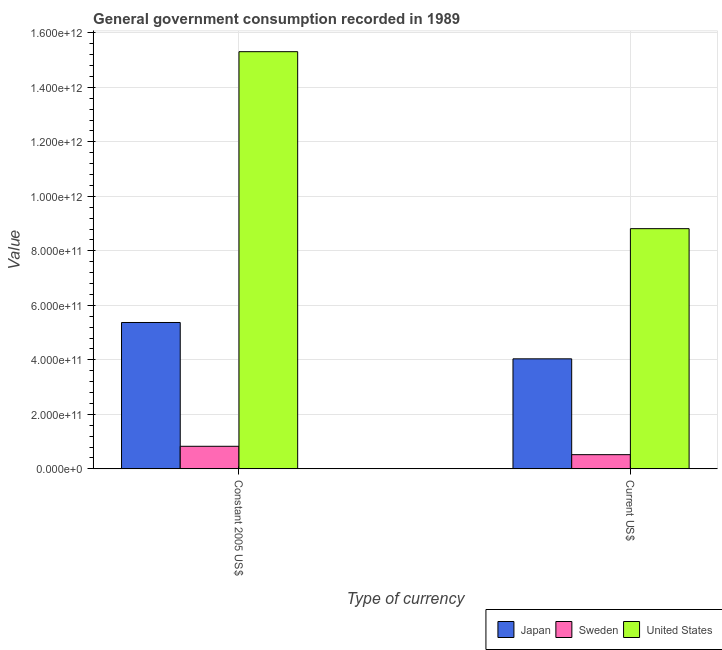How many groups of bars are there?
Your answer should be very brief. 2. Are the number of bars on each tick of the X-axis equal?
Your answer should be very brief. Yes. How many bars are there on the 2nd tick from the left?
Give a very brief answer. 3. How many bars are there on the 2nd tick from the right?
Your response must be concise. 3. What is the label of the 2nd group of bars from the left?
Make the answer very short. Current US$. What is the value consumed in current us$ in Sweden?
Offer a very short reply. 5.20e+1. Across all countries, what is the maximum value consumed in constant 2005 us$?
Your answer should be very brief. 1.53e+12. Across all countries, what is the minimum value consumed in current us$?
Make the answer very short. 5.20e+1. In which country was the value consumed in constant 2005 us$ maximum?
Offer a very short reply. United States. What is the total value consumed in current us$ in the graph?
Your answer should be very brief. 1.34e+12. What is the difference between the value consumed in current us$ in Sweden and that in Japan?
Make the answer very short. -3.52e+11. What is the difference between the value consumed in current us$ in Sweden and the value consumed in constant 2005 us$ in Japan?
Offer a terse response. -4.85e+11. What is the average value consumed in constant 2005 us$ per country?
Offer a terse response. 7.17e+11. What is the difference between the value consumed in current us$ and value consumed in constant 2005 us$ in Sweden?
Keep it short and to the point. -3.07e+1. What is the ratio of the value consumed in current us$ in Sweden to that in United States?
Your response must be concise. 0.06. In how many countries, is the value consumed in current us$ greater than the average value consumed in current us$ taken over all countries?
Your response must be concise. 1. What does the 2nd bar from the left in Current US$ represents?
Provide a short and direct response. Sweden. How many bars are there?
Offer a very short reply. 6. What is the difference between two consecutive major ticks on the Y-axis?
Keep it short and to the point. 2.00e+11. Are the values on the major ticks of Y-axis written in scientific E-notation?
Give a very brief answer. Yes. Does the graph contain any zero values?
Provide a short and direct response. No. Does the graph contain grids?
Keep it short and to the point. Yes. How are the legend labels stacked?
Offer a terse response. Horizontal. What is the title of the graph?
Offer a terse response. General government consumption recorded in 1989. What is the label or title of the X-axis?
Give a very brief answer. Type of currency. What is the label or title of the Y-axis?
Ensure brevity in your answer.  Value. What is the Value of Japan in Constant 2005 US$?
Give a very brief answer. 5.37e+11. What is the Value of Sweden in Constant 2005 US$?
Your answer should be compact. 8.28e+1. What is the Value of United States in Constant 2005 US$?
Offer a very short reply. 1.53e+12. What is the Value in Japan in Current US$?
Your response must be concise. 4.04e+11. What is the Value in Sweden in Current US$?
Your answer should be very brief. 5.20e+1. What is the Value of United States in Current US$?
Keep it short and to the point. 8.81e+11. Across all Type of currency, what is the maximum Value in Japan?
Give a very brief answer. 5.37e+11. Across all Type of currency, what is the maximum Value of Sweden?
Your response must be concise. 8.28e+1. Across all Type of currency, what is the maximum Value in United States?
Your answer should be very brief. 1.53e+12. Across all Type of currency, what is the minimum Value of Japan?
Give a very brief answer. 4.04e+11. Across all Type of currency, what is the minimum Value of Sweden?
Ensure brevity in your answer.  5.20e+1. Across all Type of currency, what is the minimum Value in United States?
Offer a very short reply. 8.81e+11. What is the total Value in Japan in the graph?
Offer a terse response. 9.41e+11. What is the total Value of Sweden in the graph?
Your answer should be very brief. 1.35e+11. What is the total Value in United States in the graph?
Offer a very short reply. 2.41e+12. What is the difference between the Value in Japan in Constant 2005 US$ and that in Current US$?
Offer a terse response. 1.33e+11. What is the difference between the Value in Sweden in Constant 2005 US$ and that in Current US$?
Keep it short and to the point. 3.07e+1. What is the difference between the Value in United States in Constant 2005 US$ and that in Current US$?
Offer a terse response. 6.50e+11. What is the difference between the Value of Japan in Constant 2005 US$ and the Value of Sweden in Current US$?
Make the answer very short. 4.85e+11. What is the difference between the Value in Japan in Constant 2005 US$ and the Value in United States in Current US$?
Your answer should be very brief. -3.44e+11. What is the difference between the Value of Sweden in Constant 2005 US$ and the Value of United States in Current US$?
Make the answer very short. -7.99e+11. What is the average Value in Japan per Type of currency?
Offer a terse response. 4.70e+11. What is the average Value of Sweden per Type of currency?
Provide a succinct answer. 6.74e+1. What is the average Value of United States per Type of currency?
Your answer should be compact. 1.21e+12. What is the difference between the Value in Japan and Value in Sweden in Constant 2005 US$?
Provide a short and direct response. 4.54e+11. What is the difference between the Value of Japan and Value of United States in Constant 2005 US$?
Provide a succinct answer. -9.94e+11. What is the difference between the Value of Sweden and Value of United States in Constant 2005 US$?
Give a very brief answer. -1.45e+12. What is the difference between the Value in Japan and Value in Sweden in Current US$?
Make the answer very short. 3.52e+11. What is the difference between the Value of Japan and Value of United States in Current US$?
Your answer should be very brief. -4.78e+11. What is the difference between the Value of Sweden and Value of United States in Current US$?
Your response must be concise. -8.29e+11. What is the ratio of the Value of Japan in Constant 2005 US$ to that in Current US$?
Provide a short and direct response. 1.33. What is the ratio of the Value of Sweden in Constant 2005 US$ to that in Current US$?
Provide a succinct answer. 1.59. What is the ratio of the Value of United States in Constant 2005 US$ to that in Current US$?
Ensure brevity in your answer.  1.74. What is the difference between the highest and the second highest Value of Japan?
Make the answer very short. 1.33e+11. What is the difference between the highest and the second highest Value in Sweden?
Provide a short and direct response. 3.07e+1. What is the difference between the highest and the second highest Value in United States?
Ensure brevity in your answer.  6.50e+11. What is the difference between the highest and the lowest Value in Japan?
Make the answer very short. 1.33e+11. What is the difference between the highest and the lowest Value of Sweden?
Provide a succinct answer. 3.07e+1. What is the difference between the highest and the lowest Value in United States?
Your answer should be compact. 6.50e+11. 